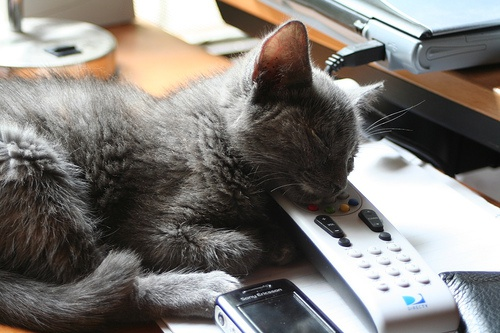Describe the objects in this image and their specific colors. I can see cat in ivory, black, gray, darkgray, and lightgray tones, remote in ivory, white, gray, black, and darkgray tones, laptop in ivory, white, gray, darkgray, and black tones, and cell phone in ivory, black, gray, and white tones in this image. 